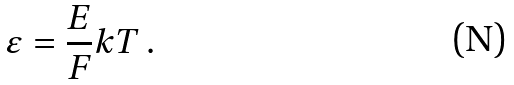<formula> <loc_0><loc_0><loc_500><loc_500>\varepsilon = \frac { E } { F } k T \, .</formula> 